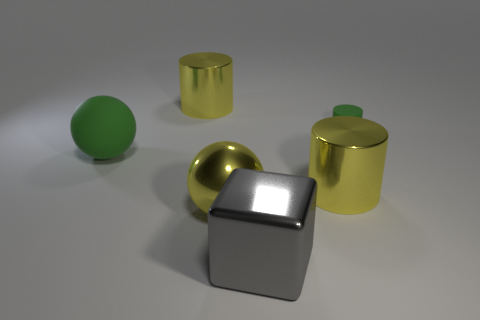Subtract 1 cylinders. How many cylinders are left? 2 Add 2 tiny matte things. How many objects exist? 8 Subtract all blocks. How many objects are left? 5 Subtract 0 yellow blocks. How many objects are left? 6 Subtract all large red shiny cylinders. Subtract all big green matte things. How many objects are left? 5 Add 3 big metallic cylinders. How many big metallic cylinders are left? 5 Add 3 big cylinders. How many big cylinders exist? 5 